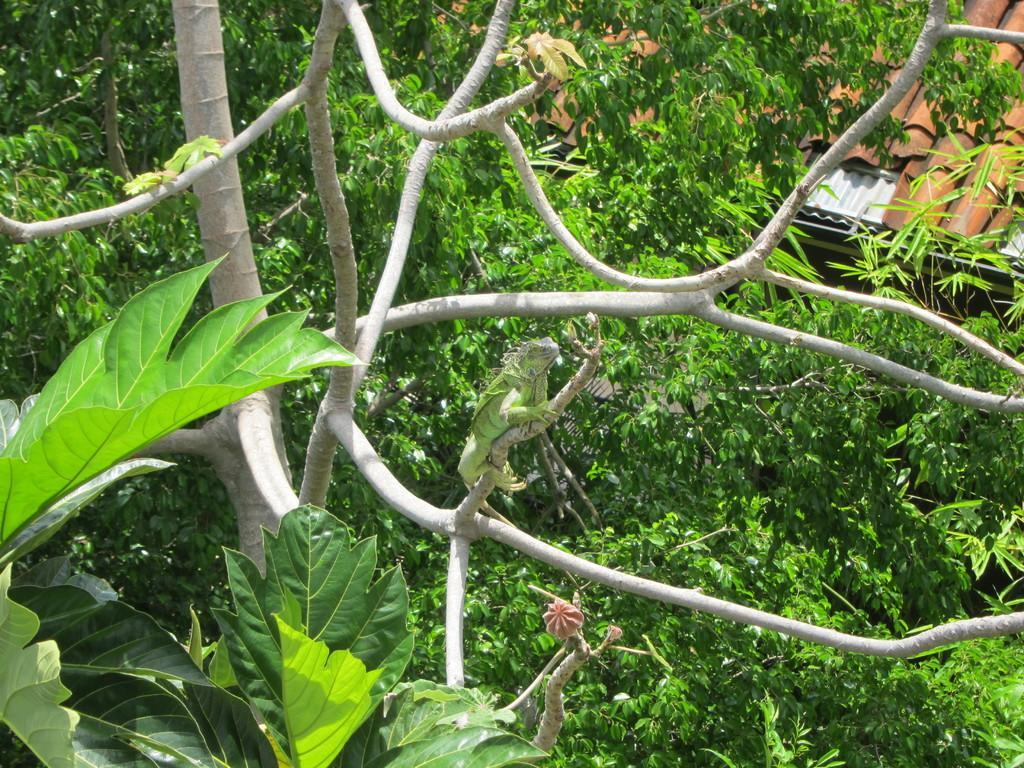Could you give a brief overview of what you see in this image? In this image I can see few trees which are green in color and on the tree I can see a reptile which is green in color. I can see the roof of the building which is brown in color. 